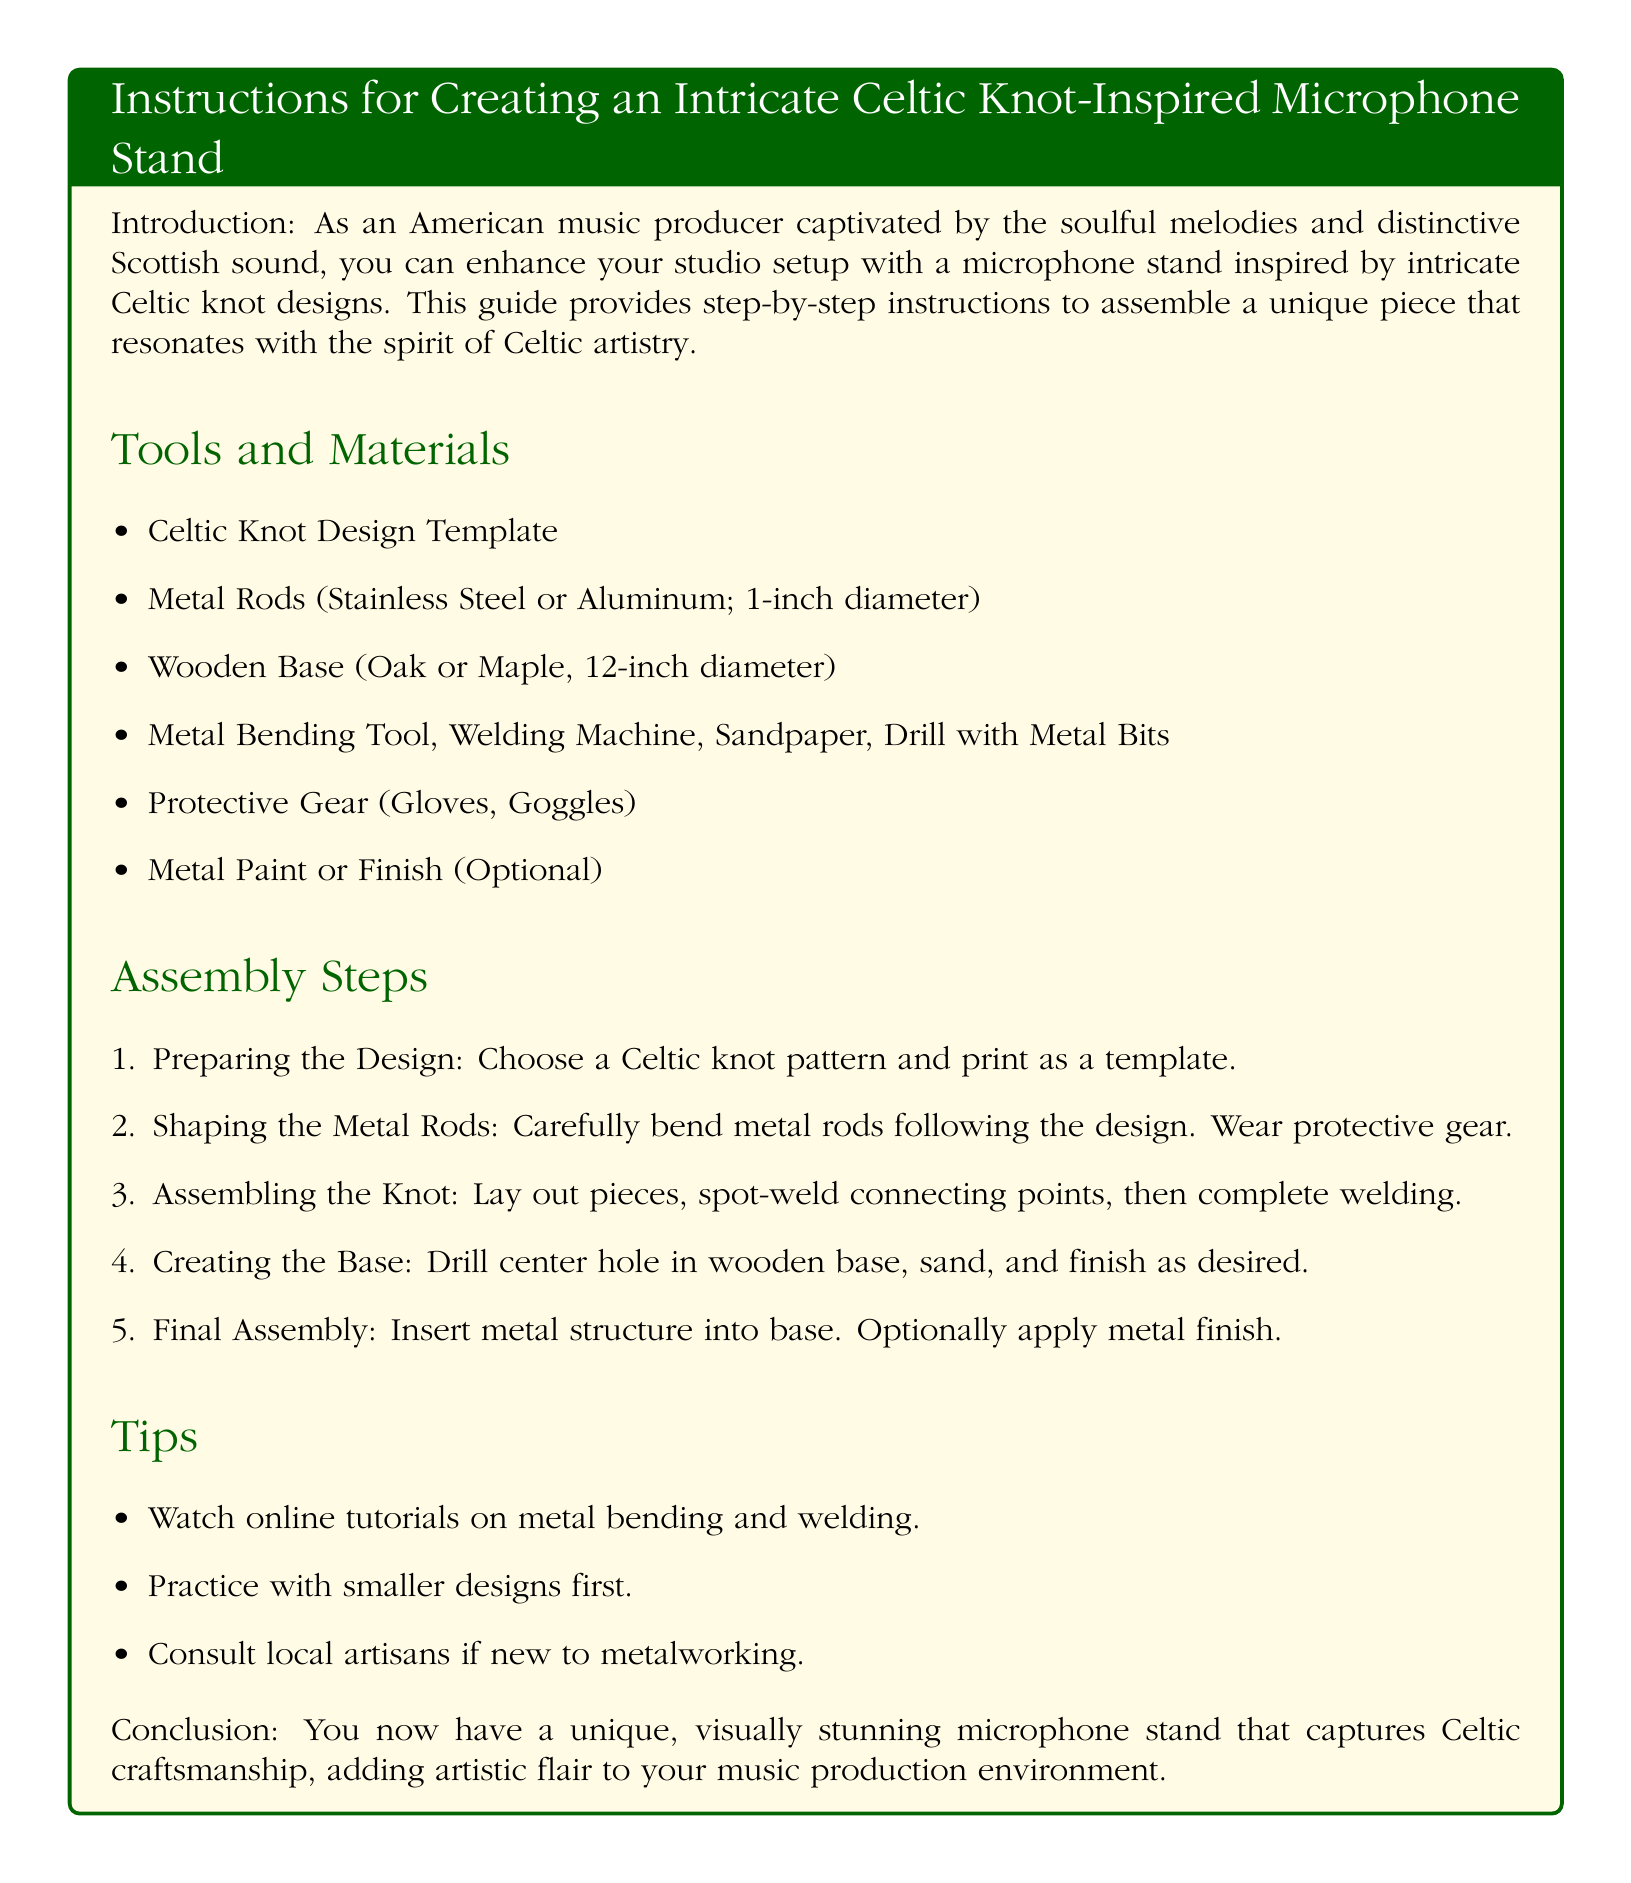what is the diameter of the wooden base? The wooden base's diameter is specified in the materials list as 12 inches.
Answer: 12-inch how many metal rods are needed? The document does not specify an exact number of metal rods needed, only that they are required.
Answer: Not specified what is used to drill the center hole in the wooden base? The assembly steps mention using a drill with metal bits to drill the center hole in the wooden base.
Answer: Drill with metal bits which protective gear is suggested? Protective gear listed includes gloves and goggles, providing safety during the assembly process.
Answer: Gloves, Goggles what should you do before welding the knot assembly? The document advises that you should carefully bend the metal rods according to the chosen design before proceeding to weld.
Answer: Bend metal rods which material is recommended for the base? The materials list suggests using Oak or Maple for the wooden base of the microphone stand.
Answer: Oak or Maple what type of tutorials does the document suggest watching? The document recommends watching online tutorials focused on metal bending and welding to assist in the assembly process.
Answer: Metal bending and welding how is the final structure secured to the base? The final assembly step involves inserting the metal structure into the base to secure it.
Answer: Insert metal structure 